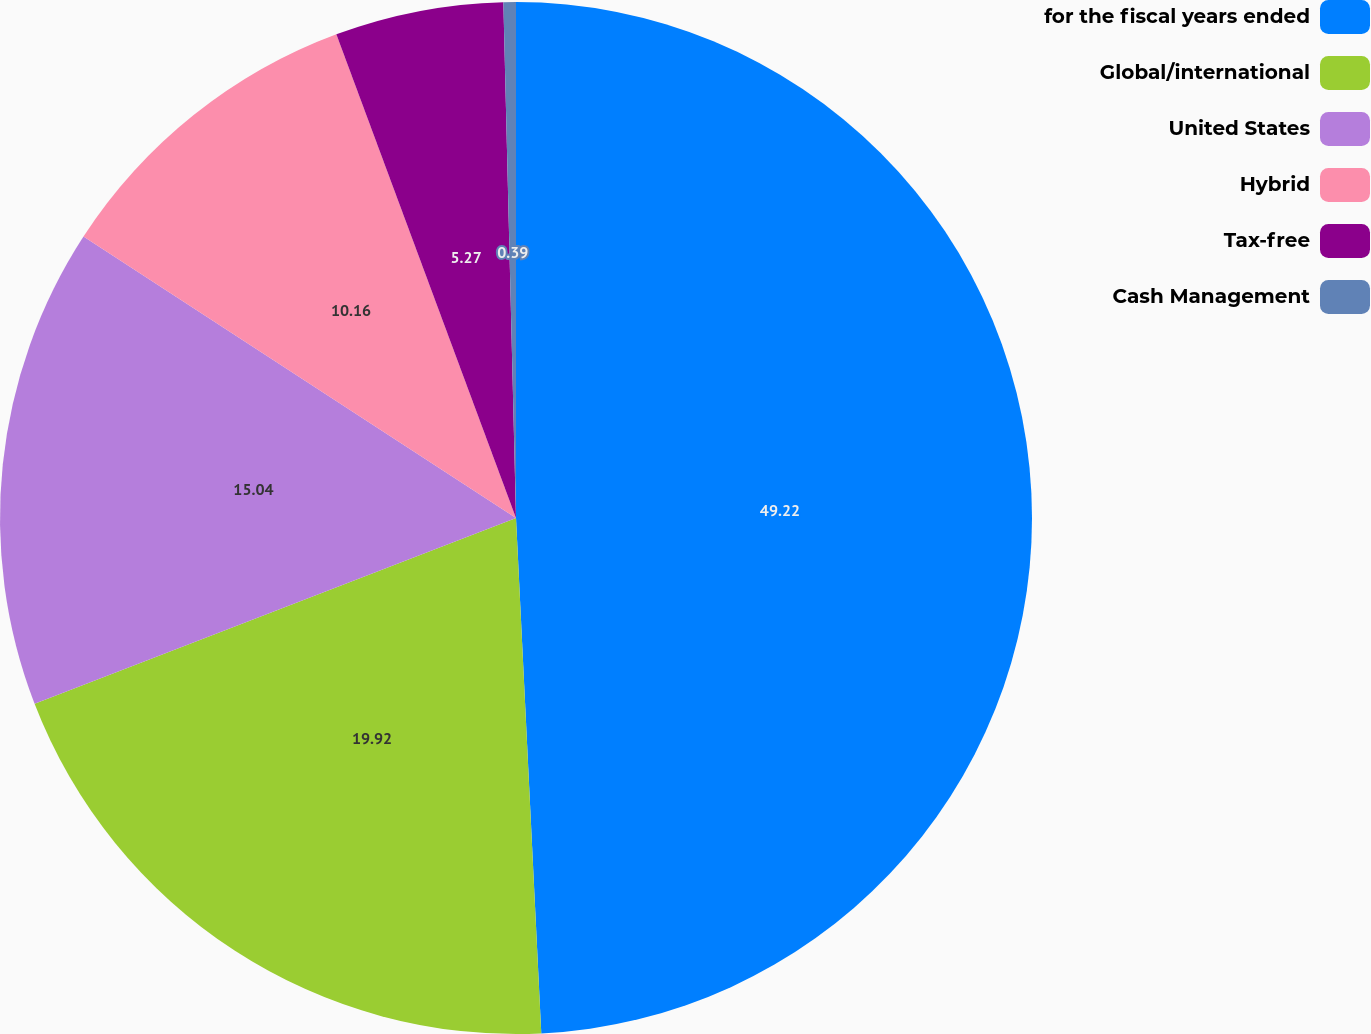Convert chart. <chart><loc_0><loc_0><loc_500><loc_500><pie_chart><fcel>for the fiscal years ended<fcel>Global/international<fcel>United States<fcel>Hybrid<fcel>Tax-free<fcel>Cash Management<nl><fcel>49.22%<fcel>19.92%<fcel>15.04%<fcel>10.16%<fcel>5.27%<fcel>0.39%<nl></chart> 